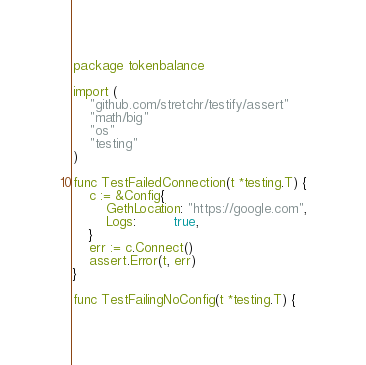Convert code to text. <code><loc_0><loc_0><loc_500><loc_500><_Go_>package tokenbalance

import (
	"github.com/stretchr/testify/assert"
	"math/big"
	"os"
	"testing"
)

func TestFailedConnection(t *testing.T) {
	c := &Config{
		GethLocation: "https://google.com",
		Logs:         true,
	}
	err := c.Connect()
	assert.Error(t, err)
}

func TestFailingNoConfig(t *testing.T) {</code> 